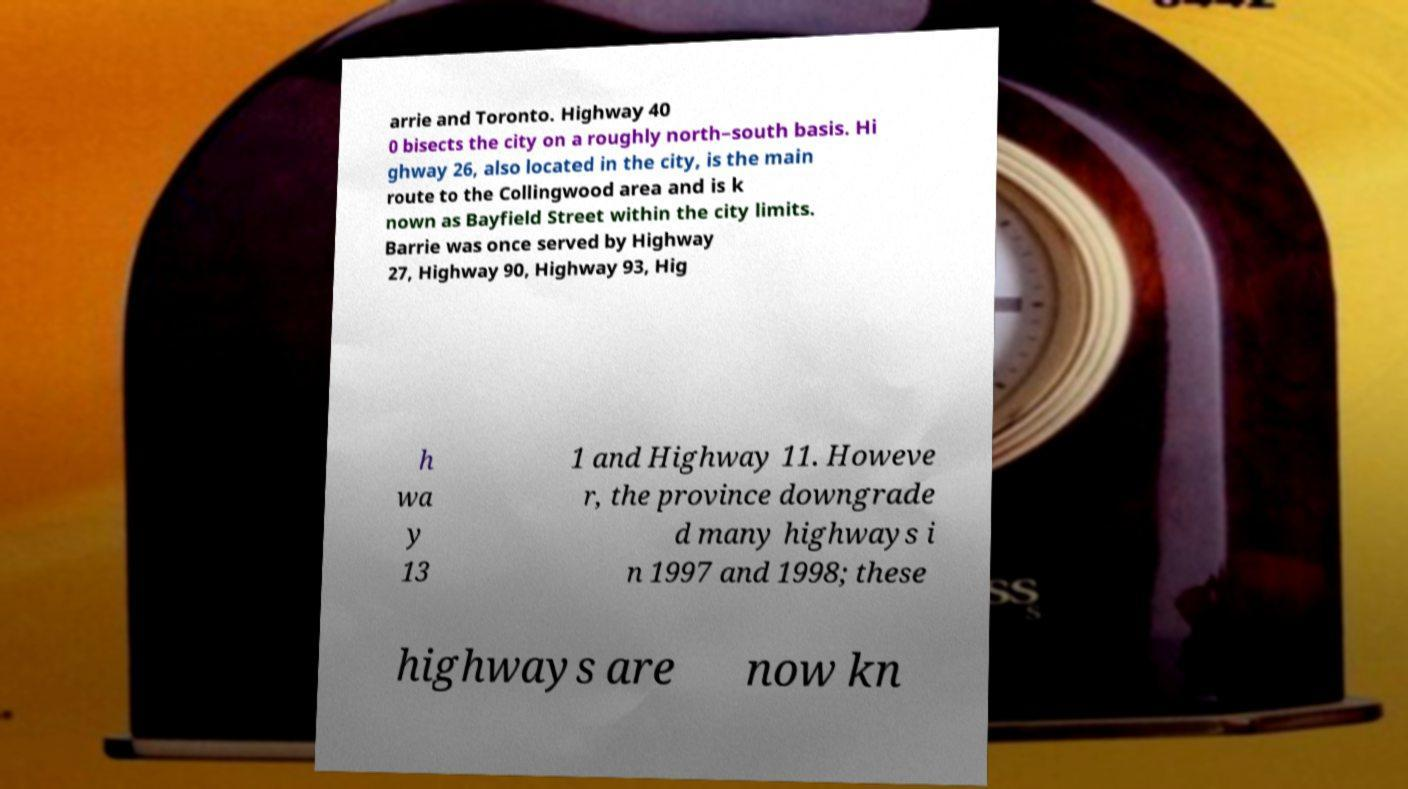Could you assist in decoding the text presented in this image and type it out clearly? arrie and Toronto. Highway 40 0 bisects the city on a roughly north–south basis. Hi ghway 26, also located in the city, is the main route to the Collingwood area and is k nown as Bayfield Street within the city limits. Barrie was once served by Highway 27, Highway 90, Highway 93, Hig h wa y 13 1 and Highway 11. Howeve r, the province downgrade d many highways i n 1997 and 1998; these highways are now kn 